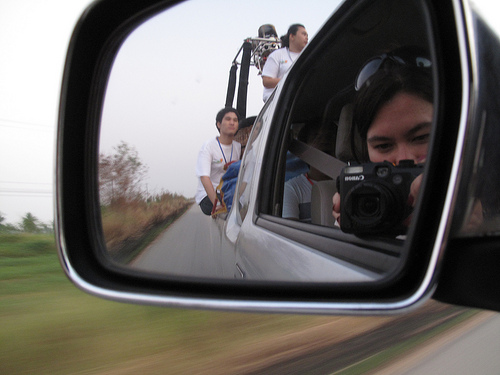<image>
Is the man on the car? Yes. Looking at the image, I can see the man is positioned on top of the car, with the car providing support. Is there a camera to the right of the lady? Yes. From this viewpoint, the camera is positioned to the right side relative to the lady. 